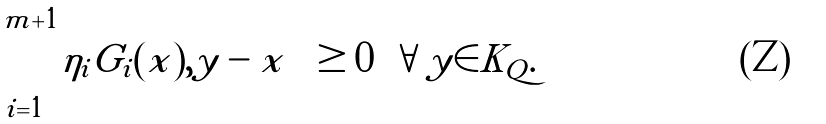<formula> <loc_0><loc_0><loc_500><loc_500>\left \langle \sum _ { i = 1 } ^ { m + 1 } \eta _ { i } G _ { i } ( x ) , y - x \right \rangle \geq 0 \ \, \forall y \in K _ { Q } .</formula> 